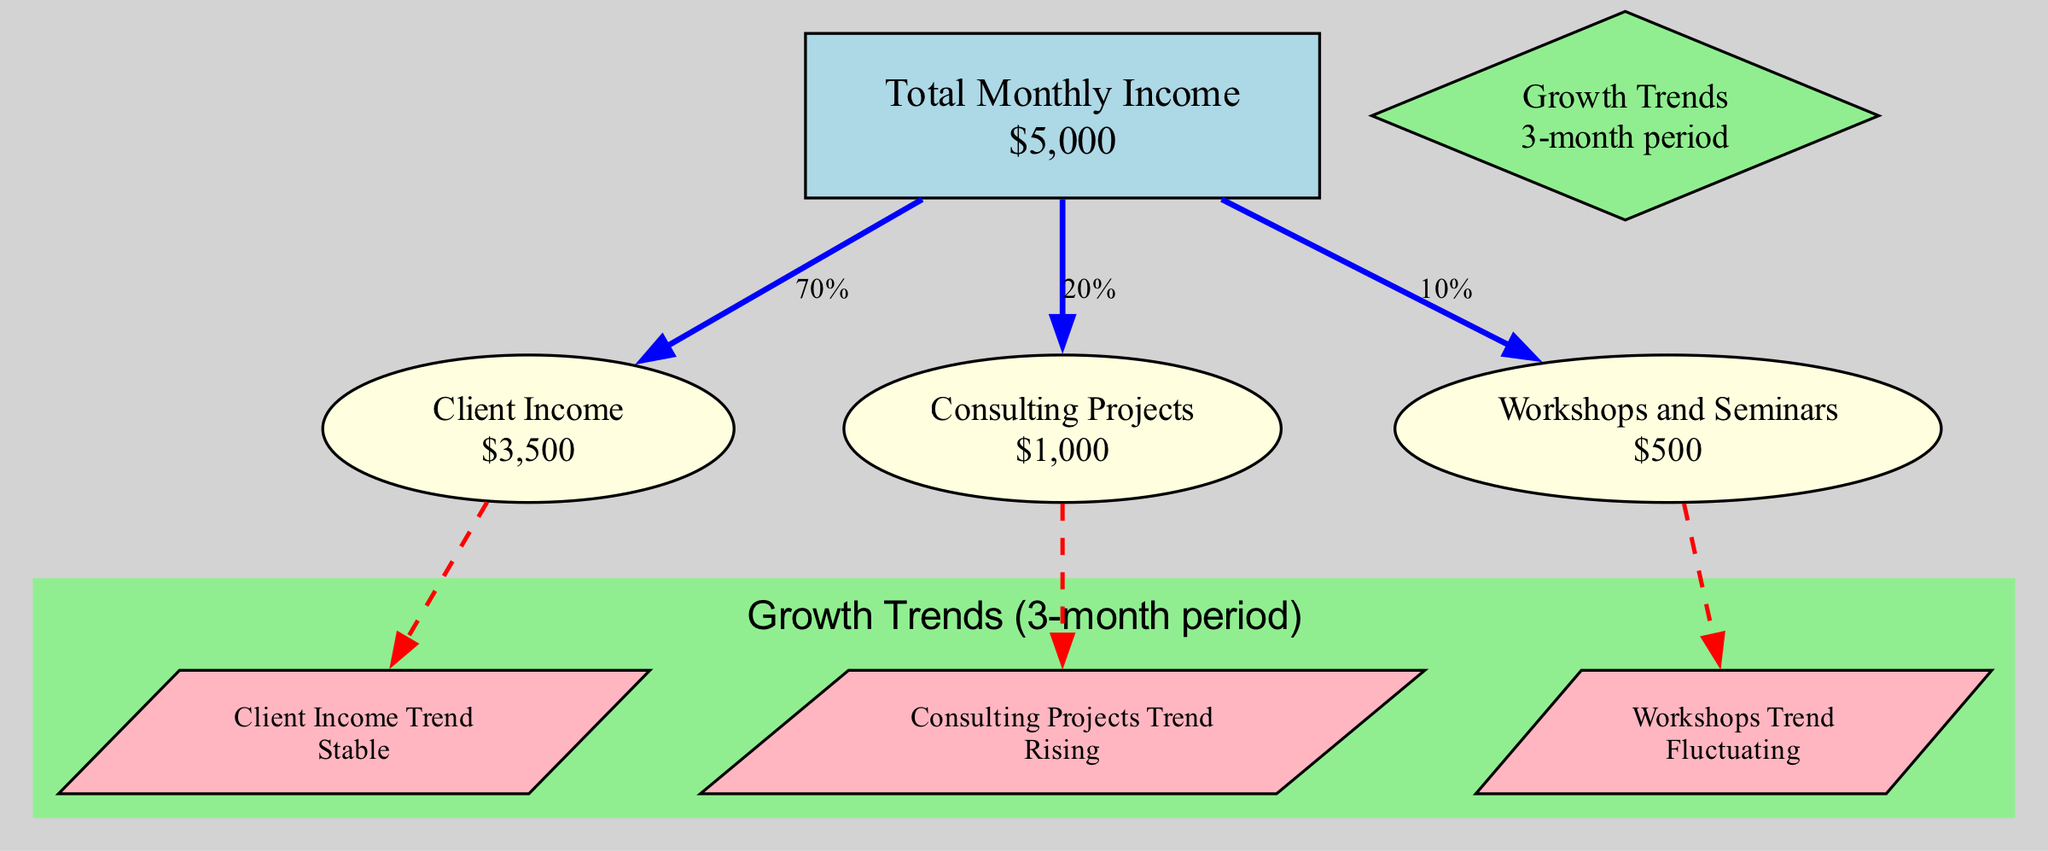what is the total monthly income? The total monthly income node indicates "$5,000" directly. This is the main metric displayed in the diagram, at the center of the income tracking.
Answer: $5,000 what percentage of total income comes from client income? The edge leading from total monthly income to client income states "70%", meaning that 70% of the total income is derived from this source.
Answer: 70% what is the value of the consulting projects? The consulting projects node clearly states "$1,000" as its value. This is the indicated revenue from consulting activities.
Answer: $1,000 which income source has a rising trend? The consulting projects trend is labeled as "Rising," indicating an expected growth in that income source. This is verified by examining the edge connecting consulting projects to its trend.
Answer: Rising how much income is generated from workshops and seminars? The node indicating workshops and seminars directly states "$500", showing the income specifically derived from this activity.
Answer: $500 what is the relationship between total monthly income and workshops and seminars? The relationship is shown through an edge labeled "10%", indicating that workshops and seminars contribute a total of 10% to the overall income. This can be found by tracing the edge from total monthly income to the workshops node.
Answer: 10% what is the client income trend? The trend associated with client income is labeled "Stable", showing consistency in income levels for this source over time. This can be found by following the edge from client income to its respective trend node.
Answer: Stable how many total sources of income are presented in the diagram? There are three distinct income source nodes present in the diagram: client income, consulting projects, and workshops and seminars; hence the total is three. This is verified by counting the source nodes shown.
Answer: 3 what type of trend is related to workshops? The trend associated with workshops is labeled "Fluctuating," indicating variability in income generation from this source. This can be traced from the workshops node to its trend.
Answer: Fluctuating 